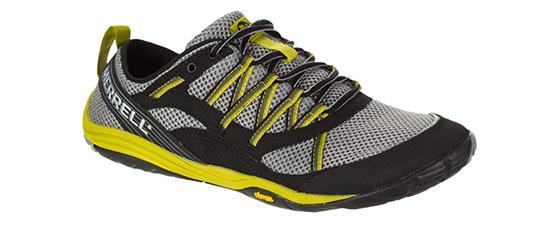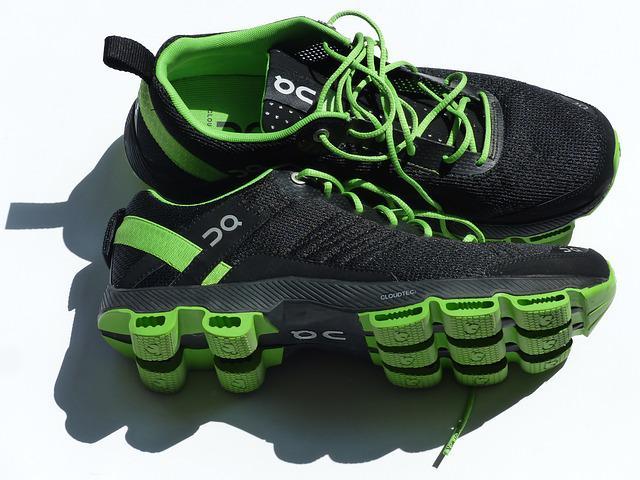The first image is the image on the left, the second image is the image on the right. Assess this claim about the two images: "The image contains two brightly colored shoes stacked on top of eachother.". Correct or not? Answer yes or no. No. The first image is the image on the left, the second image is the image on the right. Analyze the images presented: Is the assertion "In at least one image there is one shoe that is sitting on top of another shoe." valid? Answer yes or no. No. 